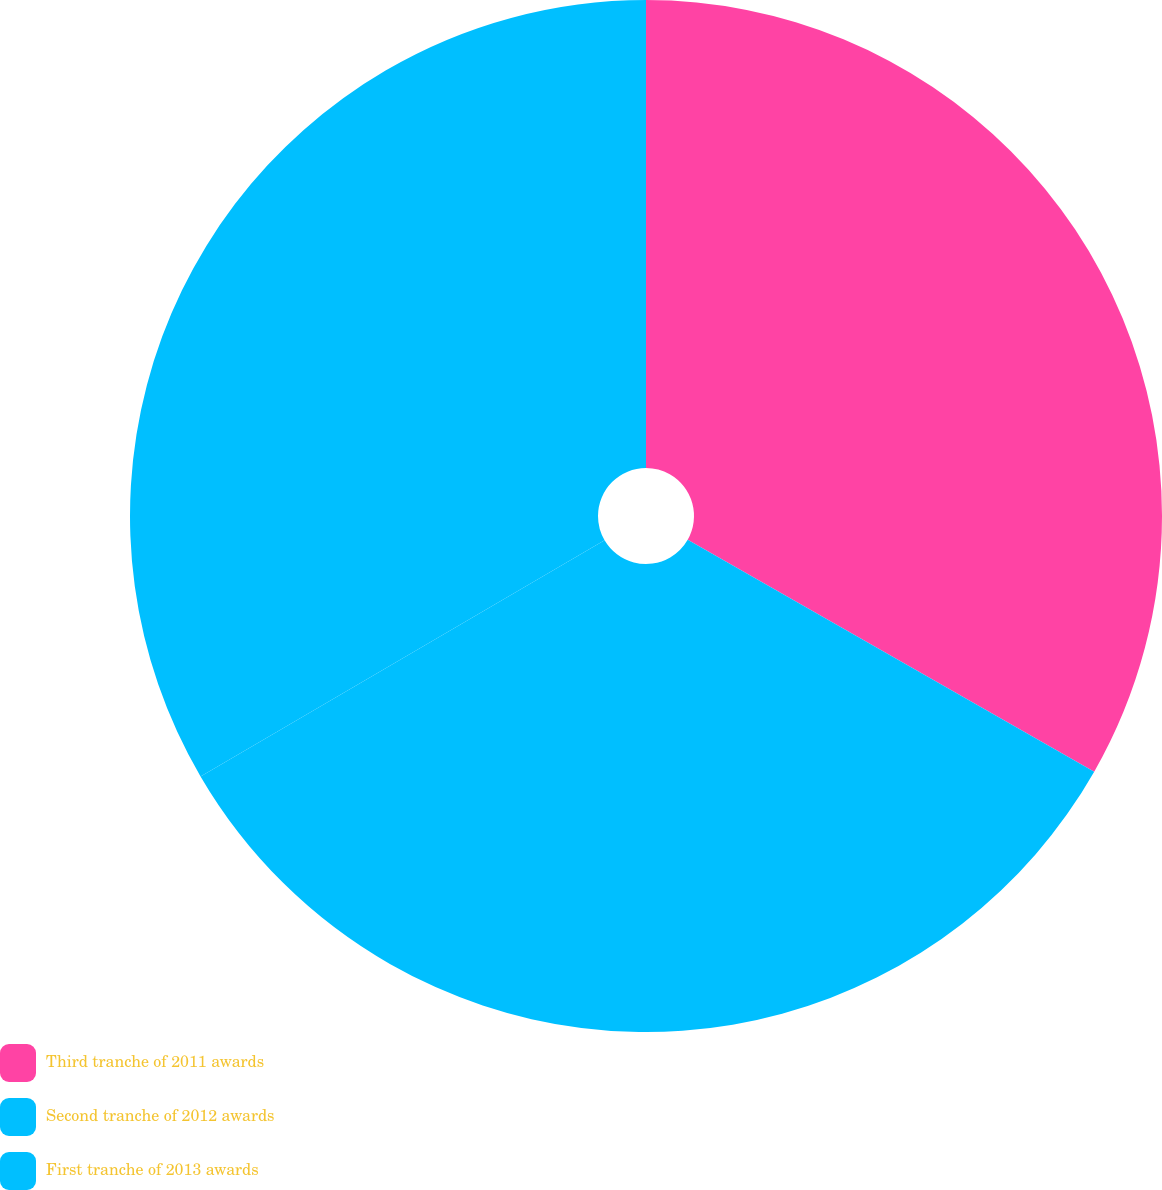<chart> <loc_0><loc_0><loc_500><loc_500><pie_chart><fcel>Third tranche of 2011 awards<fcel>Second tranche of 2012 awards<fcel>First tranche of 2013 awards<nl><fcel>33.25%<fcel>33.33%<fcel>33.42%<nl></chart> 